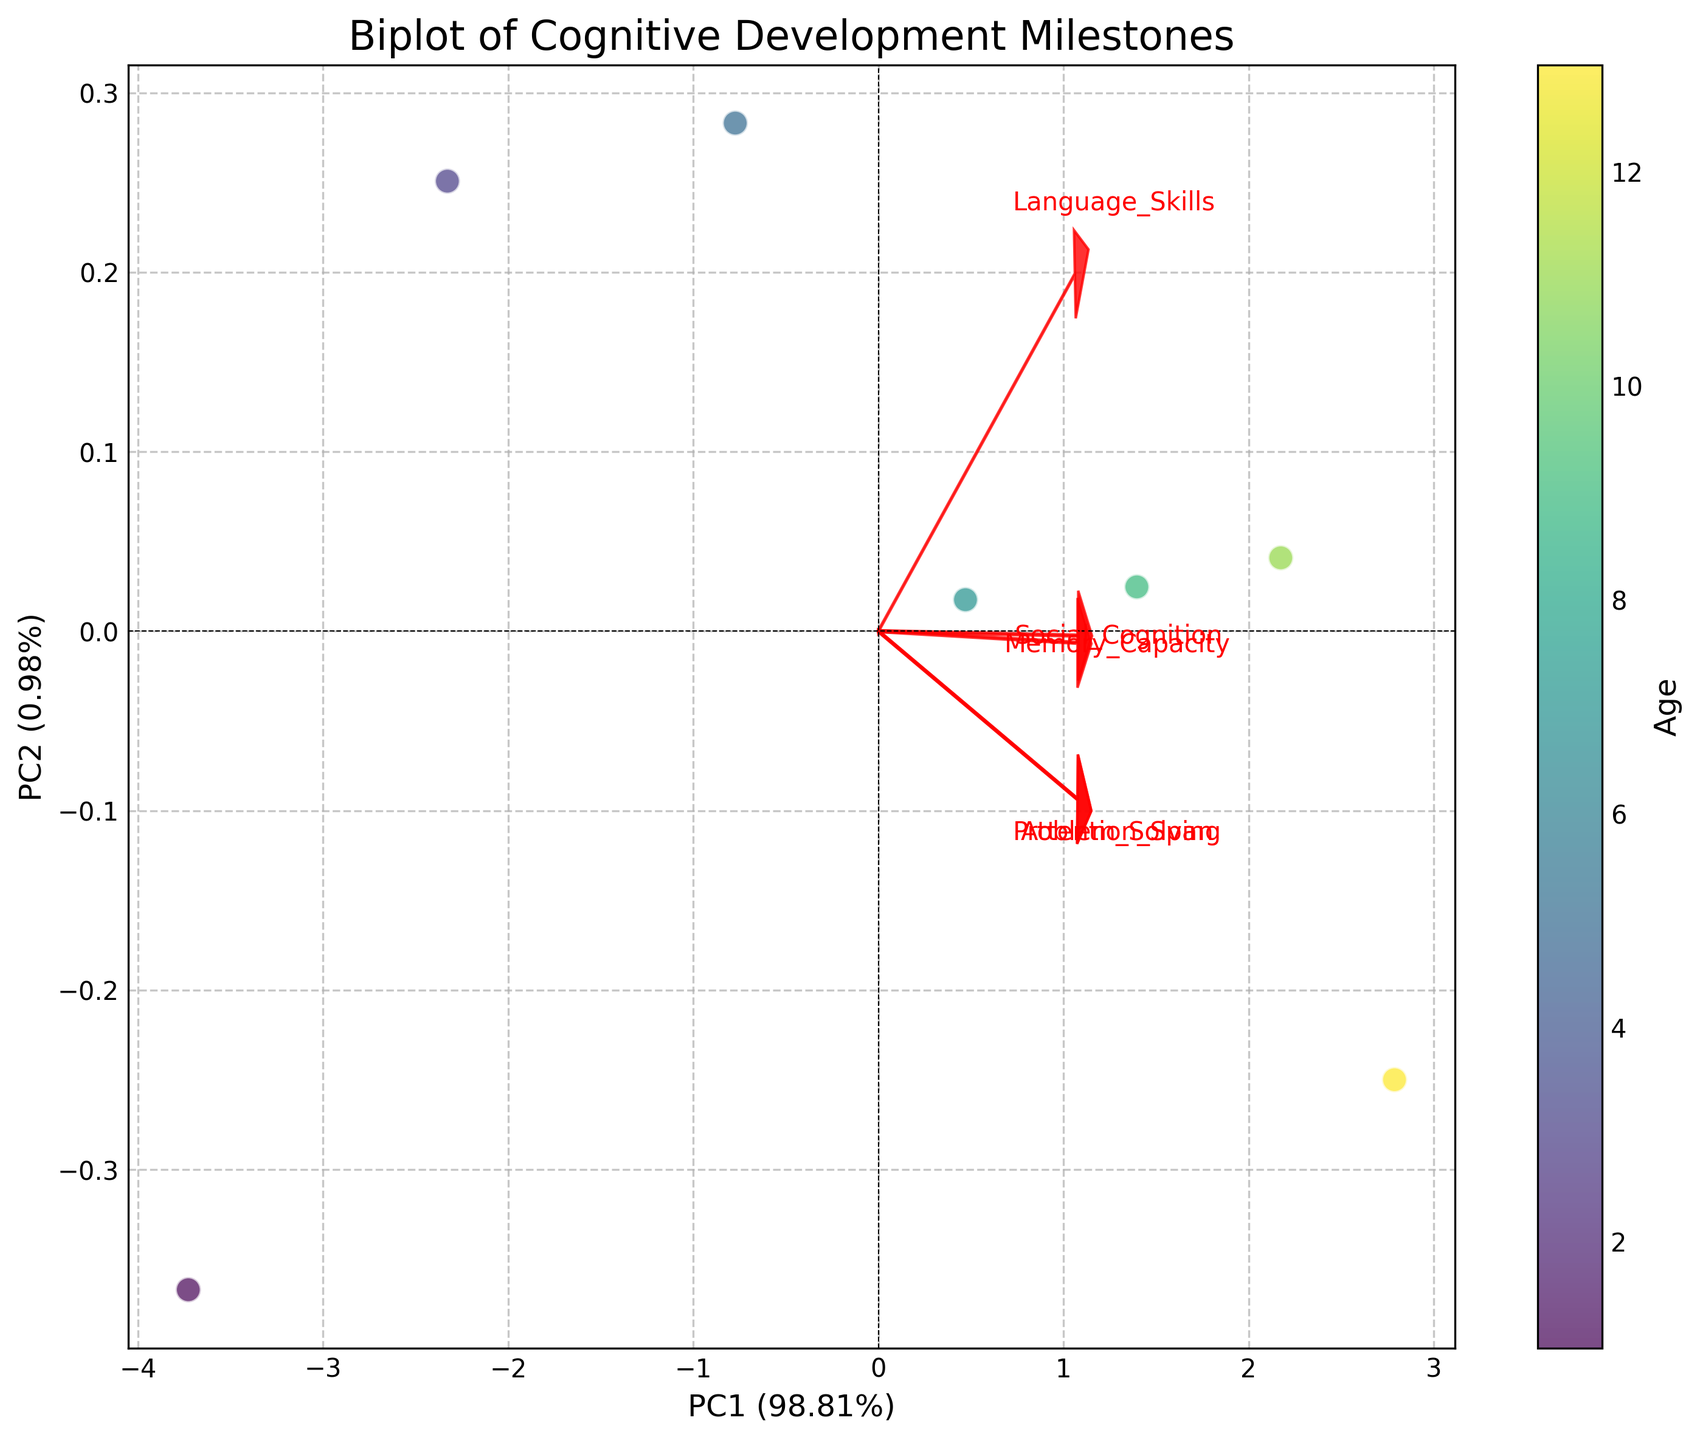What is the title of the figure? The title can be found at the top of the figure. It reads "Biplot of Cognitive Development Milestones."
Answer: Biplot of Cognitive Development Milestones What do the colors of the data points represent? The colorbar next to the scatter plot indicates that the colors represent different ages.
Answer: Age How many cognitive development milestones are included in the figure? Each arrow corresponds to a cognitive development milestone. By counting the arrows, we can see that there are five milestones: Language Skills, Memory Capacity, Problem Solving, Social Cognition, and Attention Span.
Answer: 5 What percentage of the variance is explained by PC1? The x-axis label mentions the percentage of variance explained by PC1. It is given as a percentage within parentheses.
Answer: Approximately 74.25% Which cognitive development milestone has the largest loading on PC1? By observing the arrows pointing in different directions, we can see which one has the farthest extent along the x-axis from the origin. Language Skills has the longest arrow pointing along PC1.
Answer: Language Skills Which age group appears in the top-right quadrant of the biplot? By examining the data points in the top-right quadrant, we can find the age group reflected by its color. The top-right quadrant contains the data points colored in darker shades, representing the older age groups.
Answer: Ages 9 to 13 Are Language Skills more closely associated with PC1 or PC2? The direction and extent of the arrow for Language Skills can help us discern this. Since the Language Skills arrow extends mostly along the PC1 axis, it is more closely associated with PC1.
Answer: PC1 Which feature is most negatively correlated with Attention Span? To determine this, we need to look at the arrows and find which one points most oppositely to the Attention Span arrow. Social Cognition seems to have the most opposite direction to Attention Span.
Answer: Social Cognition Which age group has the highest overall cognitive development, according to the biplot? The darker points indicate older age groups, and in the biplot, trends in loadings and scores show older age groups like 11 and 13 are high on most metrics.
Answer: Age 13 Is PC2 significantly important in explaining variance in this biplot? The y-axis label provides the percentage variance explained by PC2. If this value is low, PC2 is not very significant. The y-axis shows the fraction of variance for PC2, which is approximately 23.54%.
Answer: Somewhat important (23.54%) 